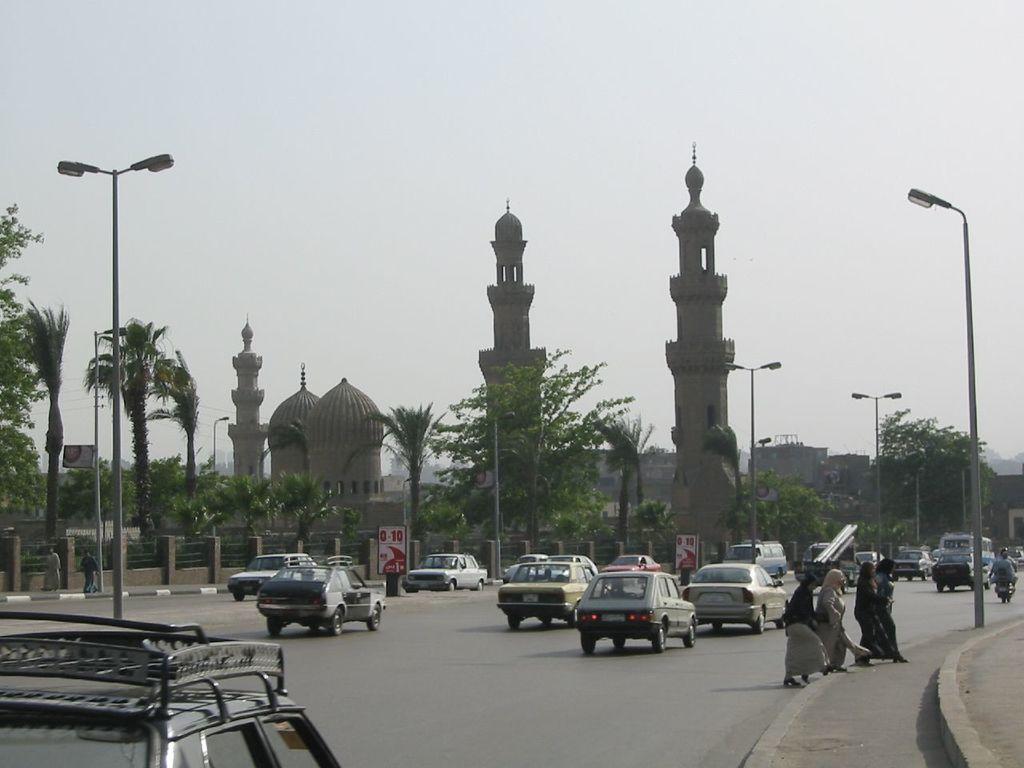Describe this image in one or two sentences. In this picture we can see some cars and vehicles traveling on the road, on the right side there are some people walking, in the background there are towers, trees, poles, lights and boards, we can see the sky at the top of the picture. 